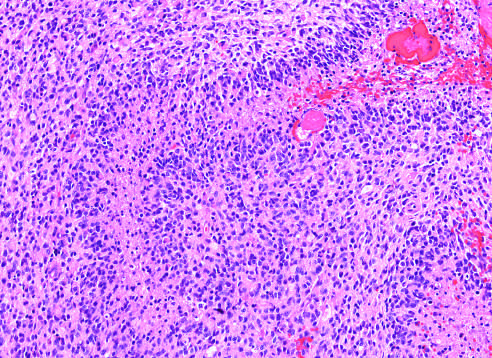what is glioblastoma?
Answer the question using a single word or phrase. A densely cellular tumor with necrosis and pseudo-palisading of tumor cell nuclei along the edge of the necrotic zone 